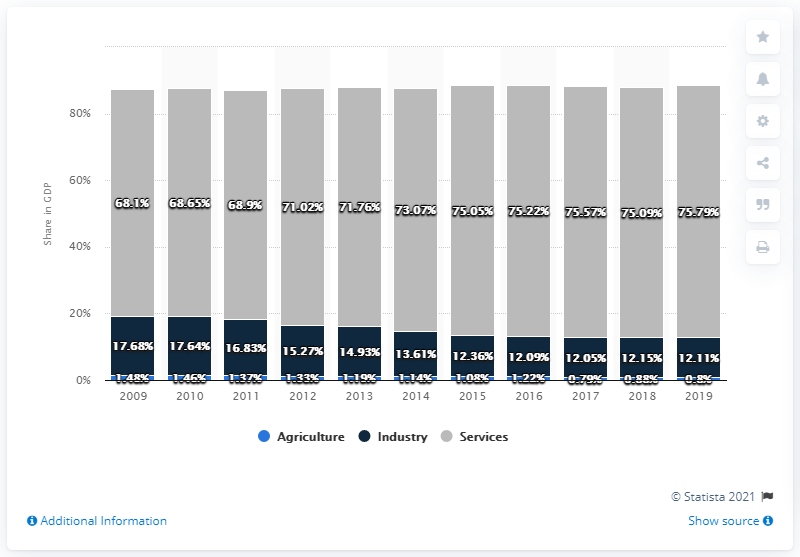Indicate a few pertinent items in this graphic. In 2019, industry accounted for 12.11% of Malta's Gross Domestic Product (GDP). In 2019, the share of agriculture in Malta's gross domestic product was 0.8%. 